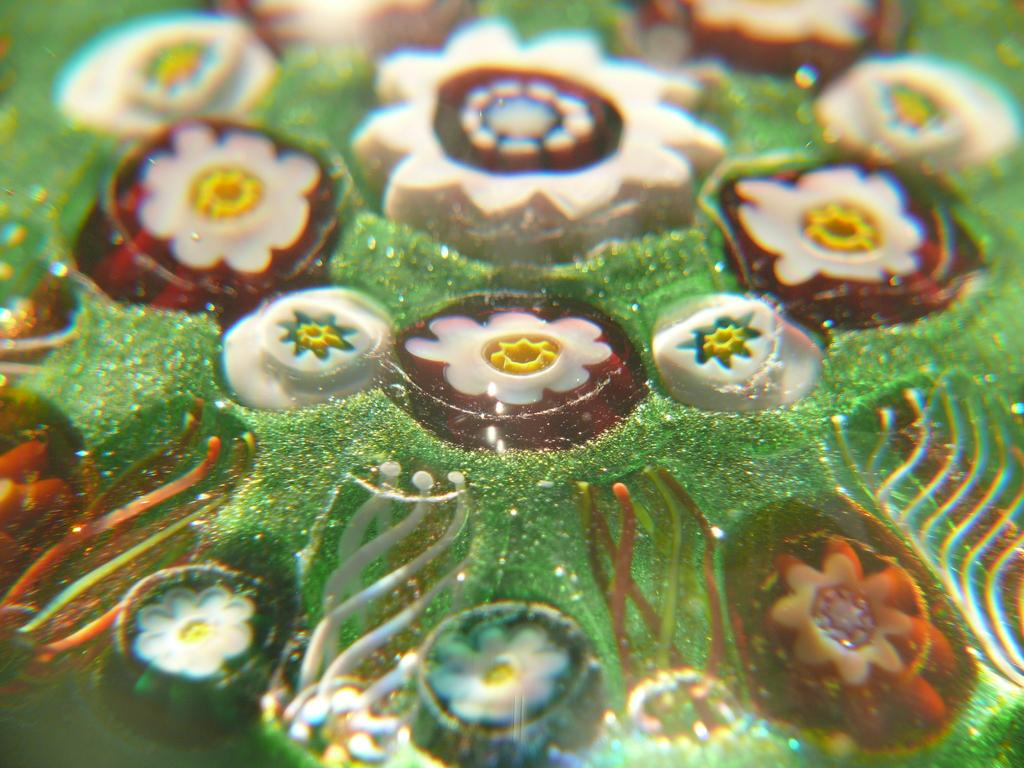What is present in the image? There is food in the image. Can you see any berries in the image? There is no information about berries in the image, so it cannot be determined if they are present or not. Are there any feet visible in the image? There is no information about feet in the image, so it cannot be determined if they are present or not. 